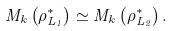<formula> <loc_0><loc_0><loc_500><loc_500>M _ { k } \left ( \rho _ { L _ { 1 } } ^ { * } \right ) \simeq M _ { k } \left ( \rho _ { L _ { 2 } } ^ { * } \right ) .</formula> 